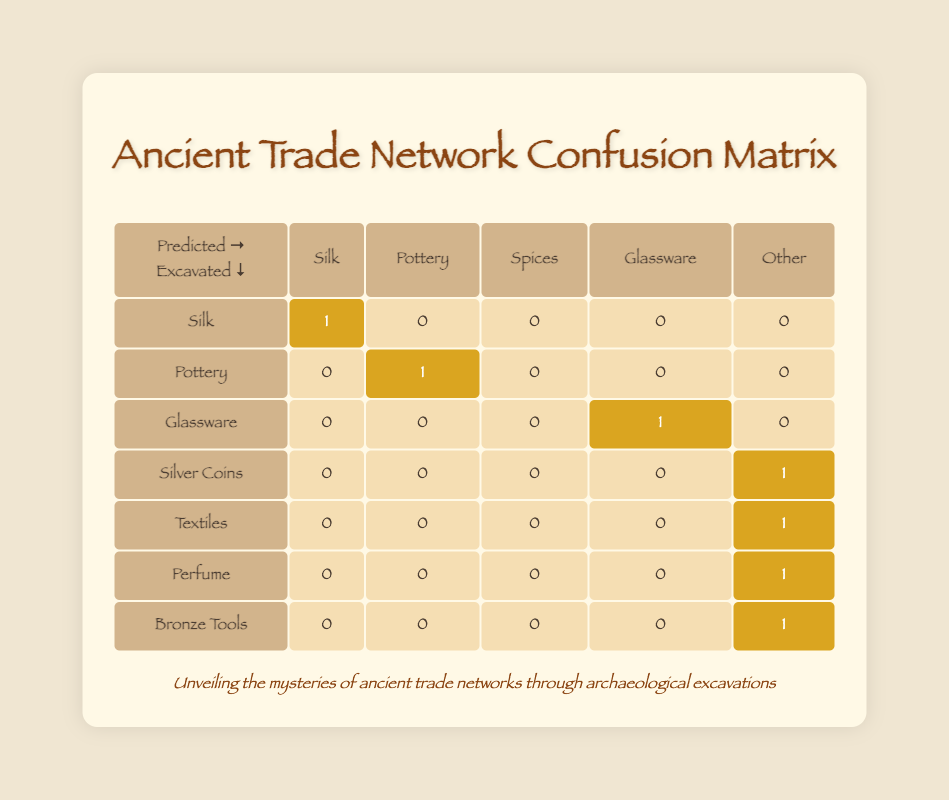What is the predicted value for Silk when excavated? The table shows that when the actual good is Silk and it is excavated, the predicted value is also Silk as indicated by the highlighted cell.
Answer: Silk How many goods were excavated as Pottery? The table indicates that there is one instance of excavated goods labeled as Pottery, as shown by the highlighted cell in the row corresponding to Pottery.
Answer: 1 Did the model correctly predict all goods that were excavated? A review of the predicted values shows discrepancies; for instance, Silver Coins predicted "Ignoring existing value" instead of a correct category, indicating the model did not predict all excavated goods correctly.
Answer: No How many total goods were predicted as "Other"? By checking the table, there's one entry labeled as "Other" in the rows for Silver Coins, Textiles, Perfume, and Bronze Tools. Adding these, we find there are 4 predictions categorized as "Other."
Answer: 4 What percentage of the goods were predicted correctly as excavated? To find the percentage of correctly predicted goods, we note that Silk, Pottery, and Glassware are correctly predicted as excavated, totaling 3. Out of 10 records, the correct prediction percentage is (3/10) * 100 = 30%.
Answer: 30% Which goods were excavated but not correctly predicted? The goods that were excavated but had incorrect predictions include Silver Coins (predicted "Ignoring existing value"), Textiles (predicted "Wool"), and Perfume (predicted "Incense").
Answer: Silver Coins, Textiles, Perfume How many goods in total were excavated? The table indicates that 8 of the goods listed were actually excavated (Silk, Pottery, Glassware, Silver Coins, Textiles, Perfume, and Bronze Tools).
Answer: 8 What is the ratio of correctly predicted goods to incorrectly predicted goods? There are 3 correctly predicted goods (Silk, Pottery, Glassware) and 7 incorrectly predicted goods as indicated in the other rows. Therefore, the ratio is 3:7.
Answer: 3:7 